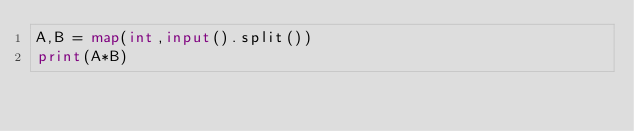<code> <loc_0><loc_0><loc_500><loc_500><_Python_>A,B = map(int,input().split())
print(A*B)</code> 